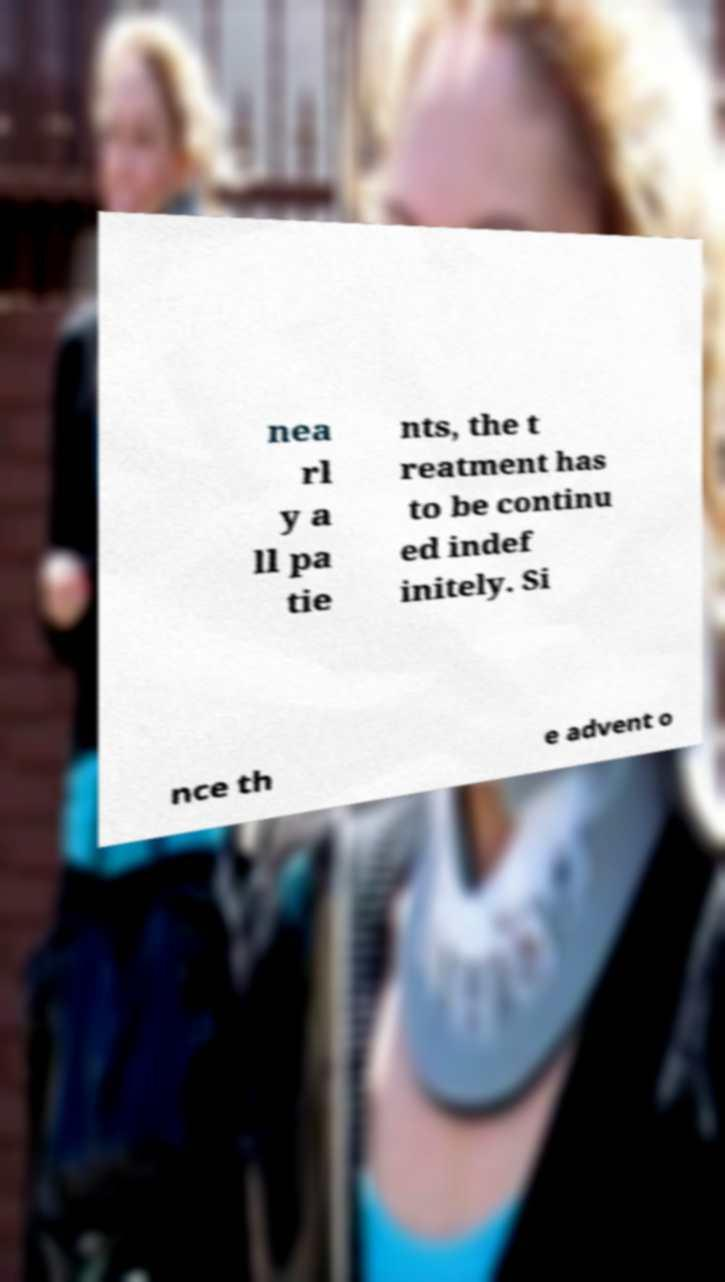What messages or text are displayed in this image? I need them in a readable, typed format. nea rl y a ll pa tie nts, the t reatment has to be continu ed indef initely. Si nce th e advent o 